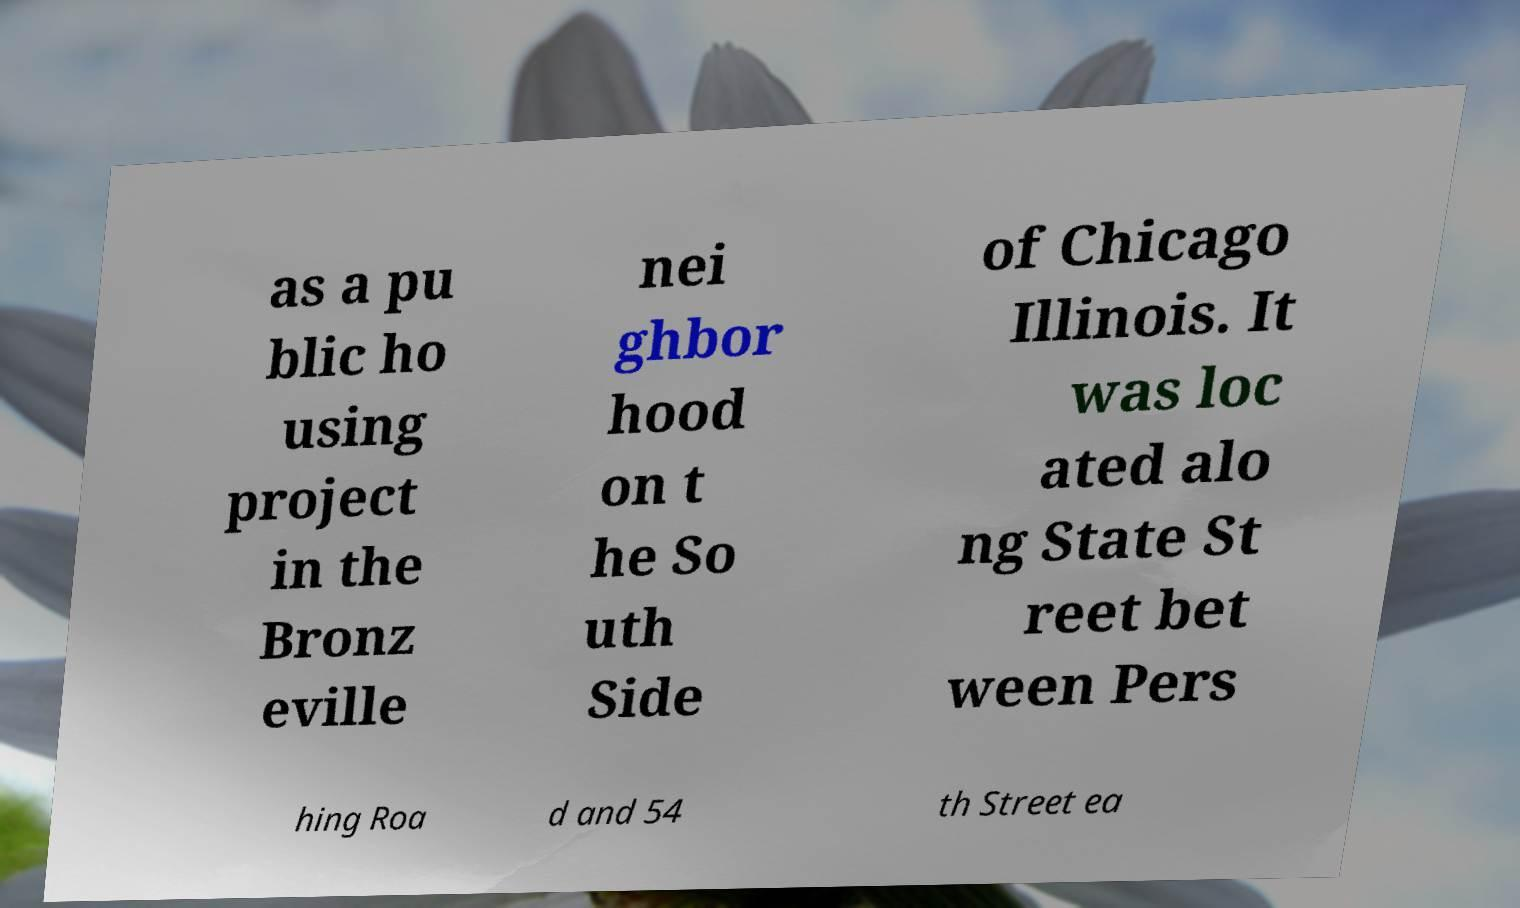Could you assist in decoding the text presented in this image and type it out clearly? as a pu blic ho using project in the Bronz eville nei ghbor hood on t he So uth Side of Chicago Illinois. It was loc ated alo ng State St reet bet ween Pers hing Roa d and 54 th Street ea 